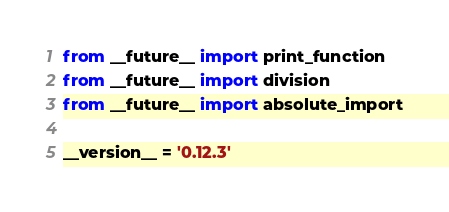Convert code to text. <code><loc_0><loc_0><loc_500><loc_500><_Python_>from __future__ import print_function
from __future__ import division
from __future__ import absolute_import

__version__ = '0.12.3'
</code> 